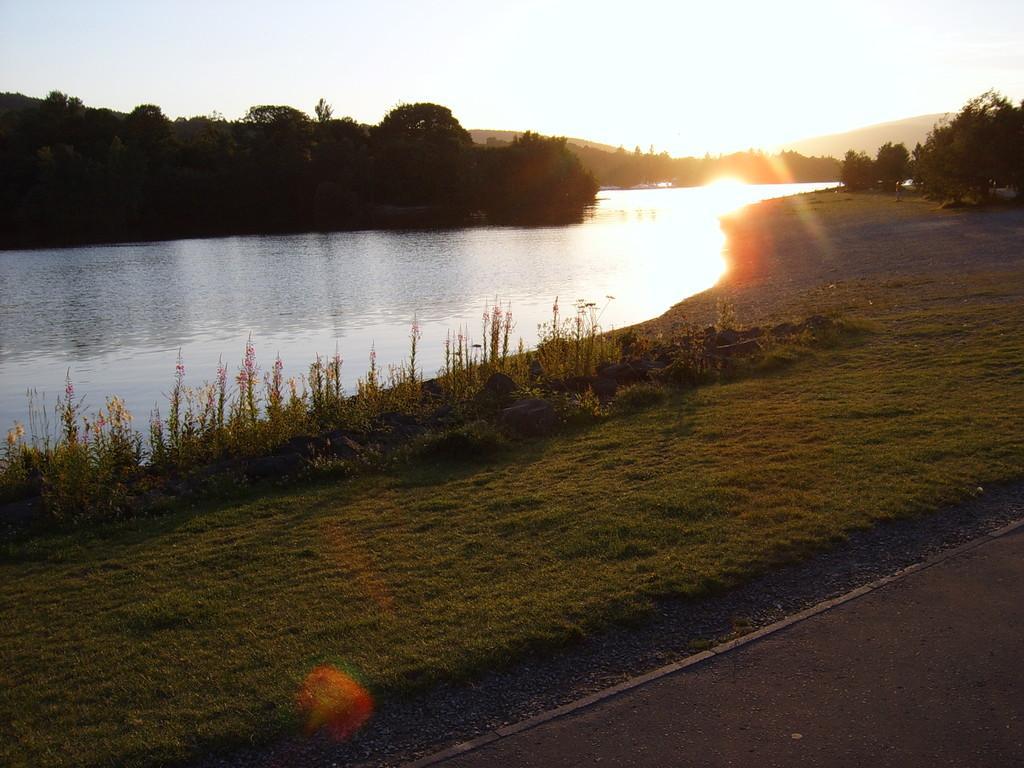Describe this image in one or two sentences. This picture is clicked in the outskirts. At the bottom of the picture, we see the grass and the road. Beside that, we see water and this water might be in a lake. There are trees in the background. At the top of the picture, we see the sky and the sun. 